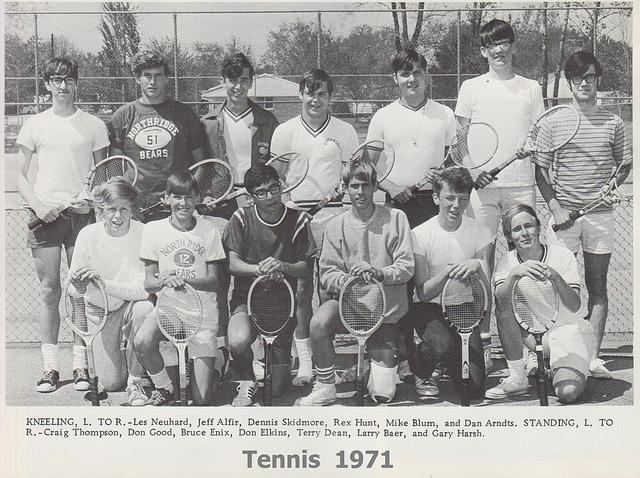What is on the boy lap?
Answer briefly. Tennis racket. Is the image in black and white?
Write a very short answer. Yes. What year team was this?
Give a very brief answer. 1971. What is the sport?
Give a very brief answer. Tennis. 